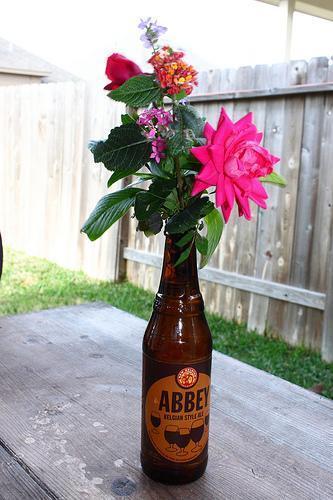How many bottles are there?
Give a very brief answer. 1. 